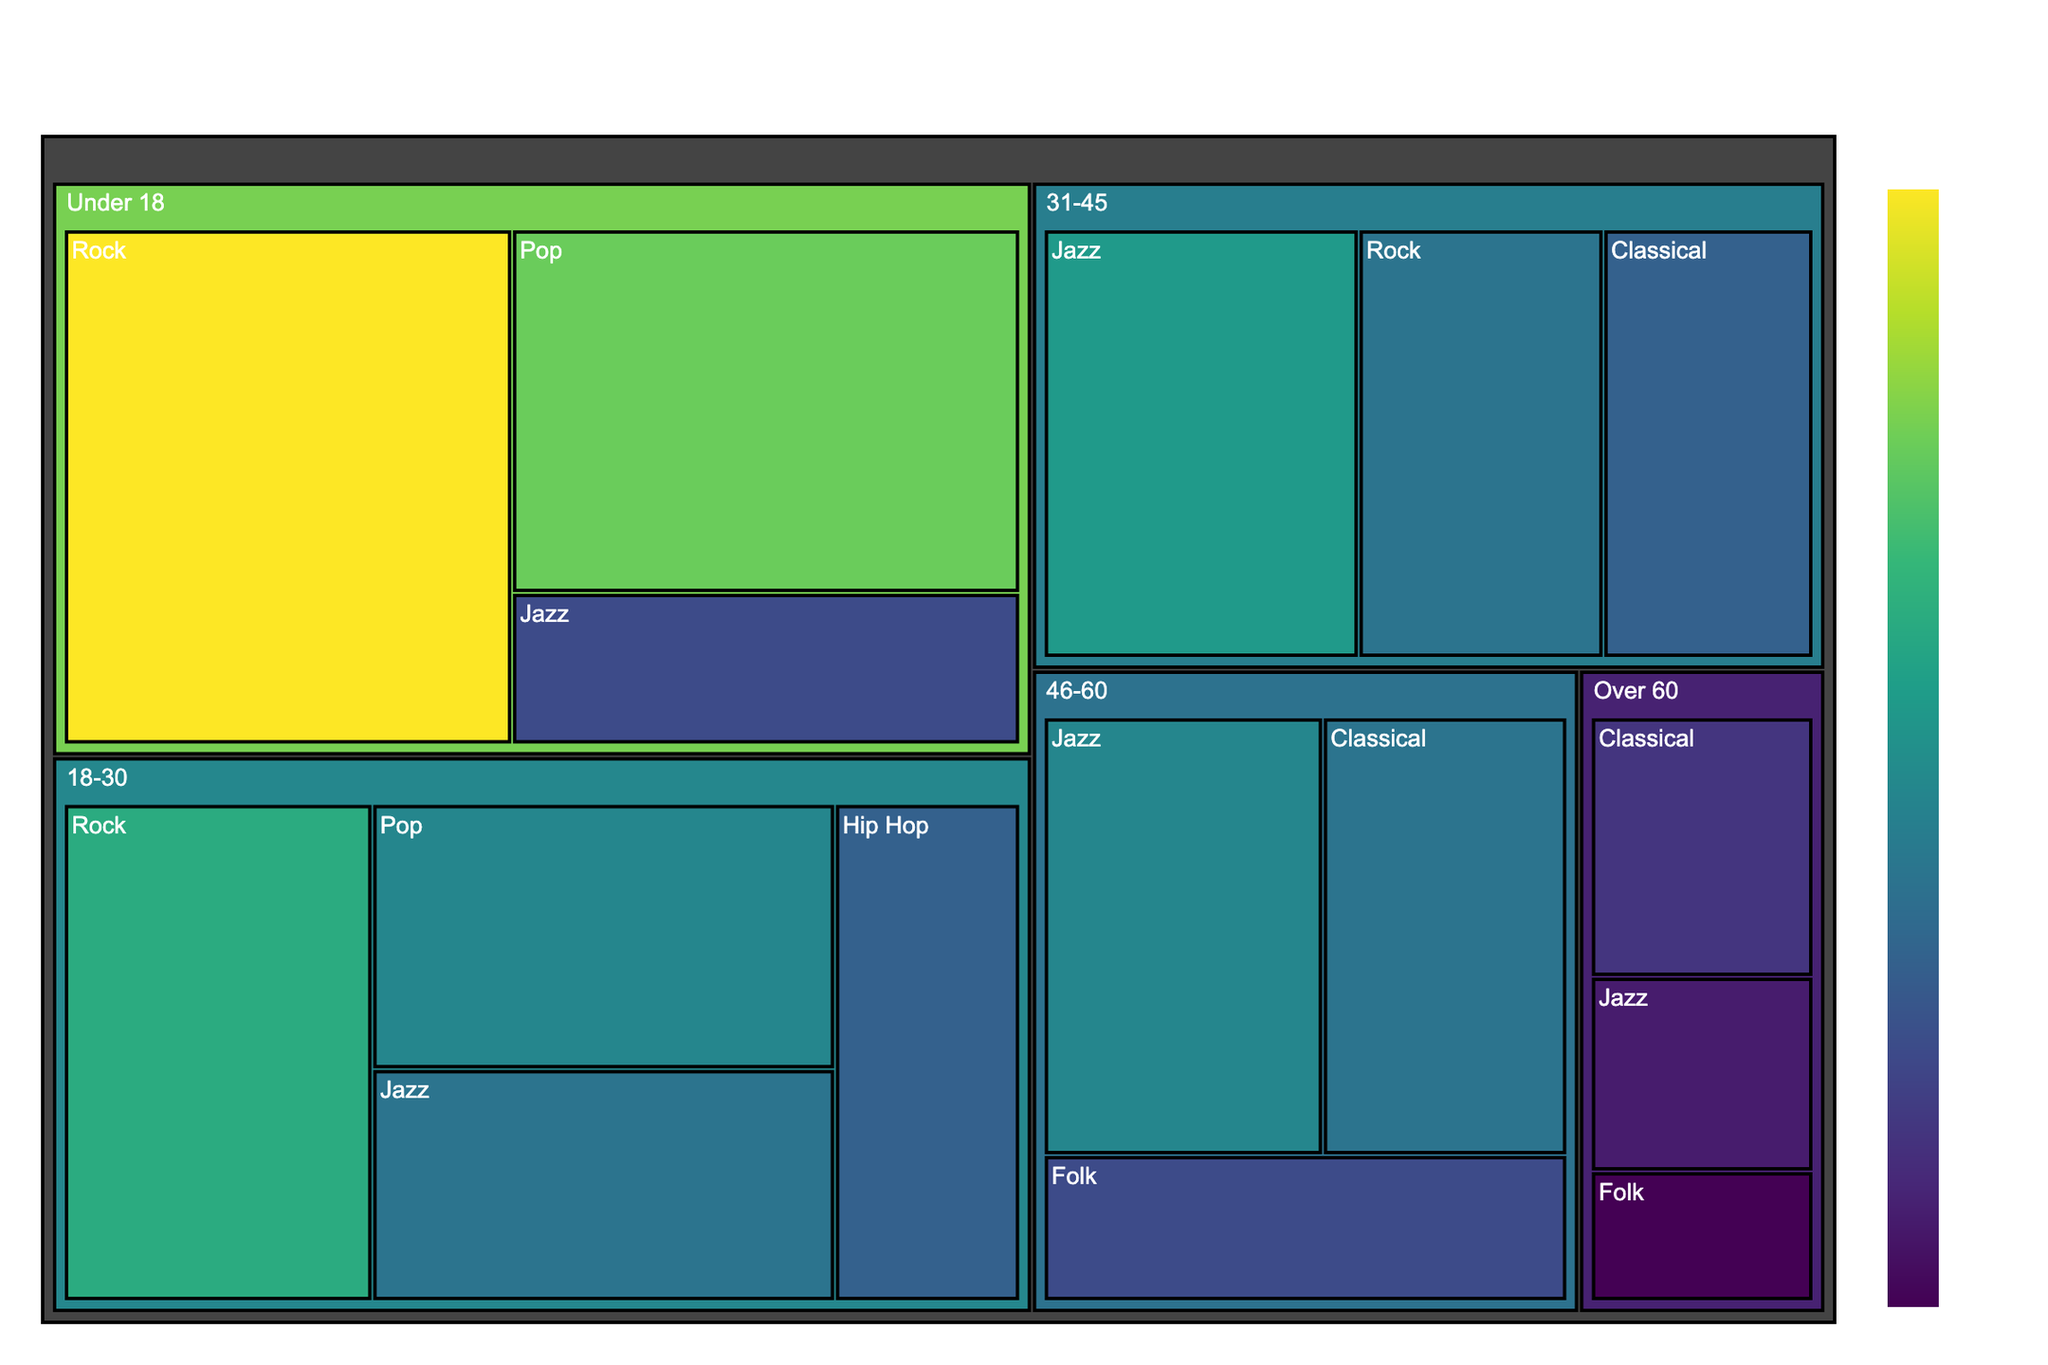How many age groups are represented in the figure? The treemap shows distinct segments for different age groups. By visually counting the unique age group segments, the age groups displayed are: Under 18, 18-30, 31-45, 46-60, and Over 60.
Answer: 5 Which age group has the highest percentage interest in Rock music? Looking at the segments within each age group for the Rock music preference, the Under 18 group shows the highest percentage at 15%.
Answer: Under 18 What's the sum percentage of interest in Jazz for the 18-30 and 31-45 age groups? Locate the Jazz segments within the 18-30 and 31-45 age groups. The percentages are 7% (18-30) and 9% (31-45). Summing these values: 7 + 9 = 16%.
Answer: 16% Which musical preference is least popular among the Over 60 age group? By examining the segments within the Over 60 age group, the Folk music preference shows the smallest percentage at 2%.
Answer: Folk Are there any age groups where Classical music is not represented? Check each age group for the presence of a Classical music segment. The Under 18 and 18-30 groups do not have segments for Classical music.
Answer: Yes, Under 18 and 18-30 Compare the interest in Pop music between the Under 18 and 18-30 age groups. Which group shows a higher percentage? By comparing the Pop music segments, Under 18 has 12%, while 18-30 has 8%. Under 18 shows a higher percentage.
Answer: Under 18 What is the combined percentage of all music preferences for the 46-60 age group? Sum the percentages of all musical preferences within the 46-60 age group: Jazz (8%), Classical (7%), Folk (5%). 8 + 7 + 5 = 20%.
Answer: 20% Which age group has the lowest overall interest across all music preferences? To find the lowest overall interest, compare the combined totals: 
- Under 18: 15 + 12 + 5 = 32%
- 18-30: 10 + 8 + 7 + 6 = 31%
- 31-45: 7 + 9 + 6 = 22%
- 46-60: 8 + 7 + 5 = 20%
- Over 60: 4 + 3 + 2 = 9%
The Over 60 group has the lowest combined percentage.
Answer: Over 60 What is the most popular music preference for the 31-45 age group? By checking the segments within the 31-45 age group, Jazz shows the highest percentage at 9%.
Answer: Jazz Which age group shows a higher percentage interest in Folk music compared to Classical music? Look at the segments for Folk and Classical within each age group. The only age group where the percentage of Folk (5%) is higher than Classical (4%) is Over 60.
Answer: Over 60 What's the difference in percentage interest in Jazz music between the 18-30 and 46-60 age groups? Comparing the Jazz segments, 18-30 has 7%, and 46-60 has 8%. The difference is calculated as 8 - 7 = 1%.
Answer: 1% 